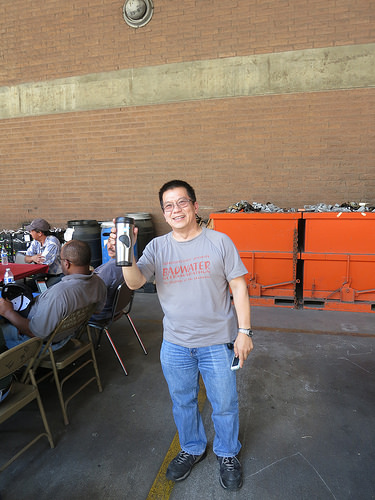<image>
Is the person on the floor? Yes. Looking at the image, I can see the person is positioned on top of the floor, with the floor providing support. Where is the cup in relation to the trash can? Is it on the trash can? No. The cup is not positioned on the trash can. They may be near each other, but the cup is not supported by or resting on top of the trash can. Is there a shoe to the right of the chair? Yes. From this viewpoint, the shoe is positioned to the right side relative to the chair. 